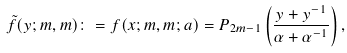<formula> <loc_0><loc_0><loc_500><loc_500>\tilde { f } ( y ; m , m ) \colon = f ( x ; m , m ; a ) = P _ { 2 m - 1 } \left ( \frac { y + y ^ { - 1 } } { \alpha + \alpha ^ { - 1 } } \right ) ,</formula> 